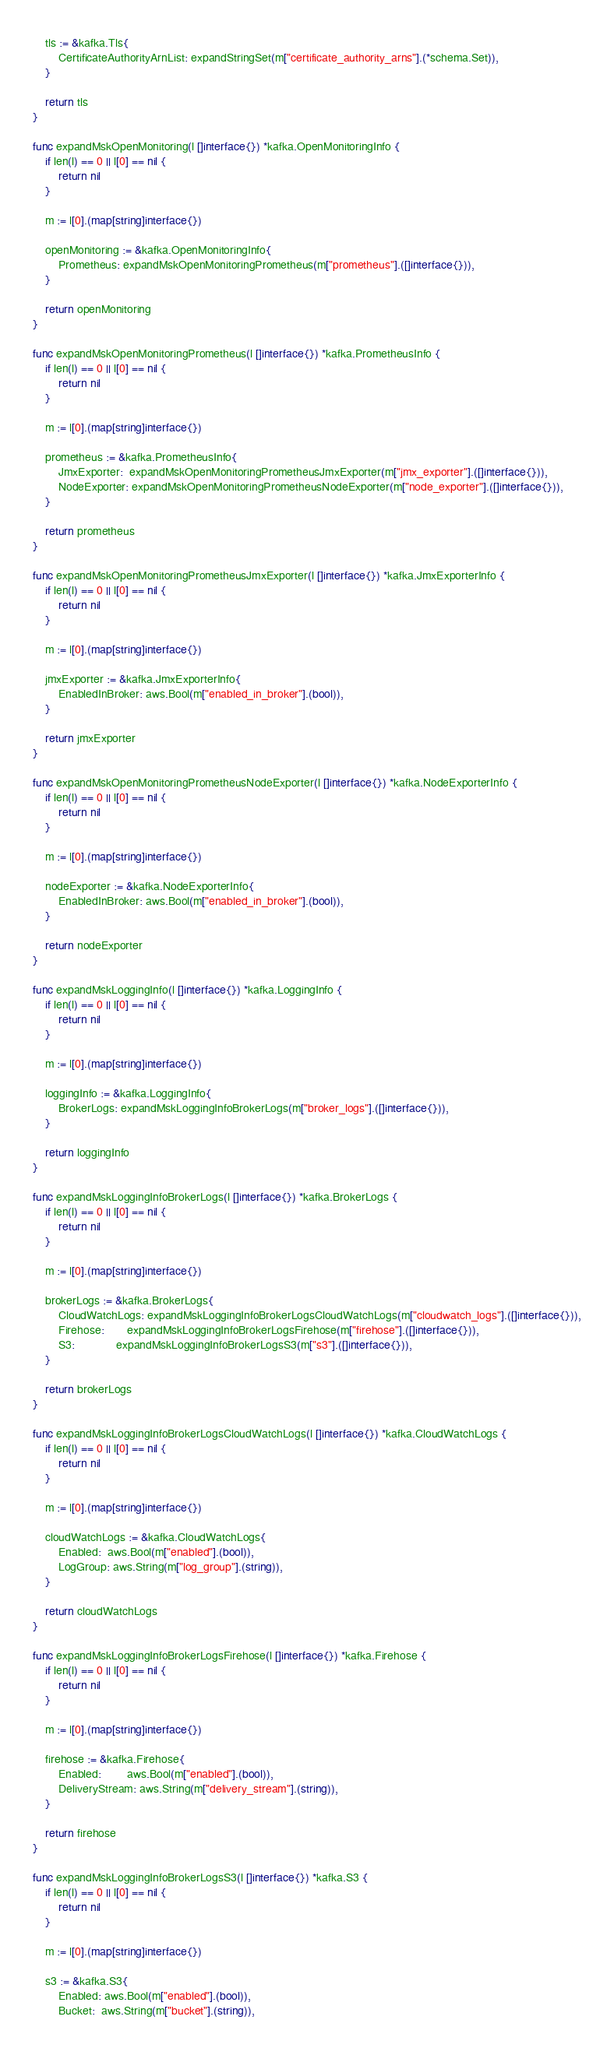Convert code to text. <code><loc_0><loc_0><loc_500><loc_500><_Go_>
	tls := &kafka.Tls{
		CertificateAuthorityArnList: expandStringSet(m["certificate_authority_arns"].(*schema.Set)),
	}

	return tls
}

func expandMskOpenMonitoring(l []interface{}) *kafka.OpenMonitoringInfo {
	if len(l) == 0 || l[0] == nil {
		return nil
	}

	m := l[0].(map[string]interface{})

	openMonitoring := &kafka.OpenMonitoringInfo{
		Prometheus: expandMskOpenMonitoringPrometheus(m["prometheus"].([]interface{})),
	}

	return openMonitoring
}

func expandMskOpenMonitoringPrometheus(l []interface{}) *kafka.PrometheusInfo {
	if len(l) == 0 || l[0] == nil {
		return nil
	}

	m := l[0].(map[string]interface{})

	prometheus := &kafka.PrometheusInfo{
		JmxExporter:  expandMskOpenMonitoringPrometheusJmxExporter(m["jmx_exporter"].([]interface{})),
		NodeExporter: expandMskOpenMonitoringPrometheusNodeExporter(m["node_exporter"].([]interface{})),
	}

	return prometheus
}

func expandMskOpenMonitoringPrometheusJmxExporter(l []interface{}) *kafka.JmxExporterInfo {
	if len(l) == 0 || l[0] == nil {
		return nil
	}

	m := l[0].(map[string]interface{})

	jmxExporter := &kafka.JmxExporterInfo{
		EnabledInBroker: aws.Bool(m["enabled_in_broker"].(bool)),
	}

	return jmxExporter
}

func expandMskOpenMonitoringPrometheusNodeExporter(l []interface{}) *kafka.NodeExporterInfo {
	if len(l) == 0 || l[0] == nil {
		return nil
	}

	m := l[0].(map[string]interface{})

	nodeExporter := &kafka.NodeExporterInfo{
		EnabledInBroker: aws.Bool(m["enabled_in_broker"].(bool)),
	}

	return nodeExporter
}

func expandMskLoggingInfo(l []interface{}) *kafka.LoggingInfo {
	if len(l) == 0 || l[0] == nil {
		return nil
	}

	m := l[0].(map[string]interface{})

	loggingInfo := &kafka.LoggingInfo{
		BrokerLogs: expandMskLoggingInfoBrokerLogs(m["broker_logs"].([]interface{})),
	}

	return loggingInfo
}

func expandMskLoggingInfoBrokerLogs(l []interface{}) *kafka.BrokerLogs {
	if len(l) == 0 || l[0] == nil {
		return nil
	}

	m := l[0].(map[string]interface{})

	brokerLogs := &kafka.BrokerLogs{
		CloudWatchLogs: expandMskLoggingInfoBrokerLogsCloudWatchLogs(m["cloudwatch_logs"].([]interface{})),
		Firehose:       expandMskLoggingInfoBrokerLogsFirehose(m["firehose"].([]interface{})),
		S3:             expandMskLoggingInfoBrokerLogsS3(m["s3"].([]interface{})),
	}

	return brokerLogs
}

func expandMskLoggingInfoBrokerLogsCloudWatchLogs(l []interface{}) *kafka.CloudWatchLogs {
	if len(l) == 0 || l[0] == nil {
		return nil
	}

	m := l[0].(map[string]interface{})

	cloudWatchLogs := &kafka.CloudWatchLogs{
		Enabled:  aws.Bool(m["enabled"].(bool)),
		LogGroup: aws.String(m["log_group"].(string)),
	}

	return cloudWatchLogs
}

func expandMskLoggingInfoBrokerLogsFirehose(l []interface{}) *kafka.Firehose {
	if len(l) == 0 || l[0] == nil {
		return nil
	}

	m := l[0].(map[string]interface{})

	firehose := &kafka.Firehose{
		Enabled:        aws.Bool(m["enabled"].(bool)),
		DeliveryStream: aws.String(m["delivery_stream"].(string)),
	}

	return firehose
}

func expandMskLoggingInfoBrokerLogsS3(l []interface{}) *kafka.S3 {
	if len(l) == 0 || l[0] == nil {
		return nil
	}

	m := l[0].(map[string]interface{})

	s3 := &kafka.S3{
		Enabled: aws.Bool(m["enabled"].(bool)),
		Bucket:  aws.String(m["bucket"].(string)),</code> 